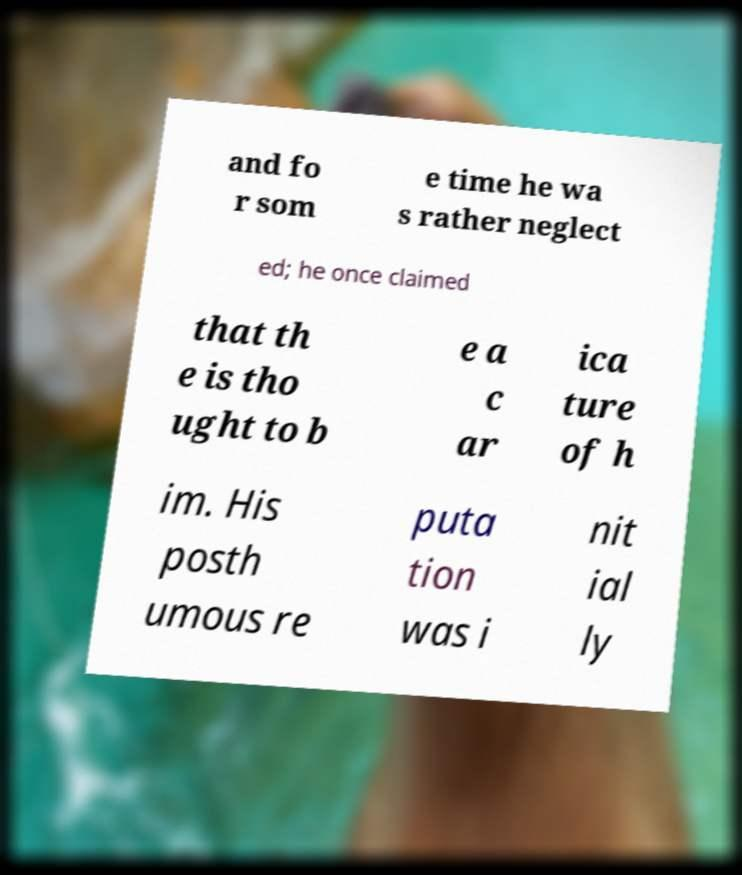Please identify and transcribe the text found in this image. and fo r som e time he wa s rather neglect ed; he once claimed that th e is tho ught to b e a c ar ica ture of h im. His posth umous re puta tion was i nit ial ly 